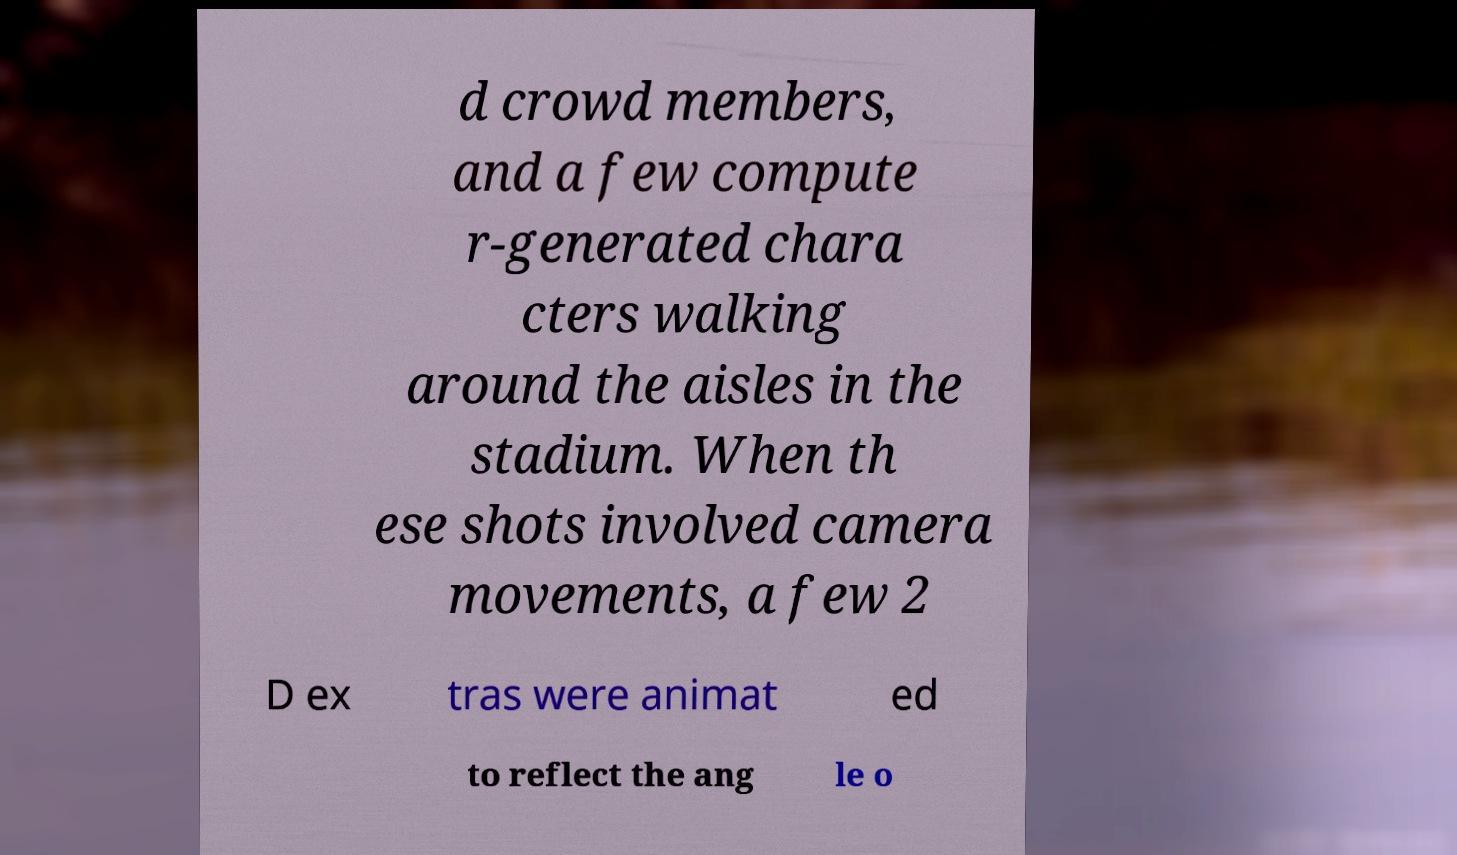Can you read and provide the text displayed in the image?This photo seems to have some interesting text. Can you extract and type it out for me? d crowd members, and a few compute r-generated chara cters walking around the aisles in the stadium. When th ese shots involved camera movements, a few 2 D ex tras were animat ed to reflect the ang le o 